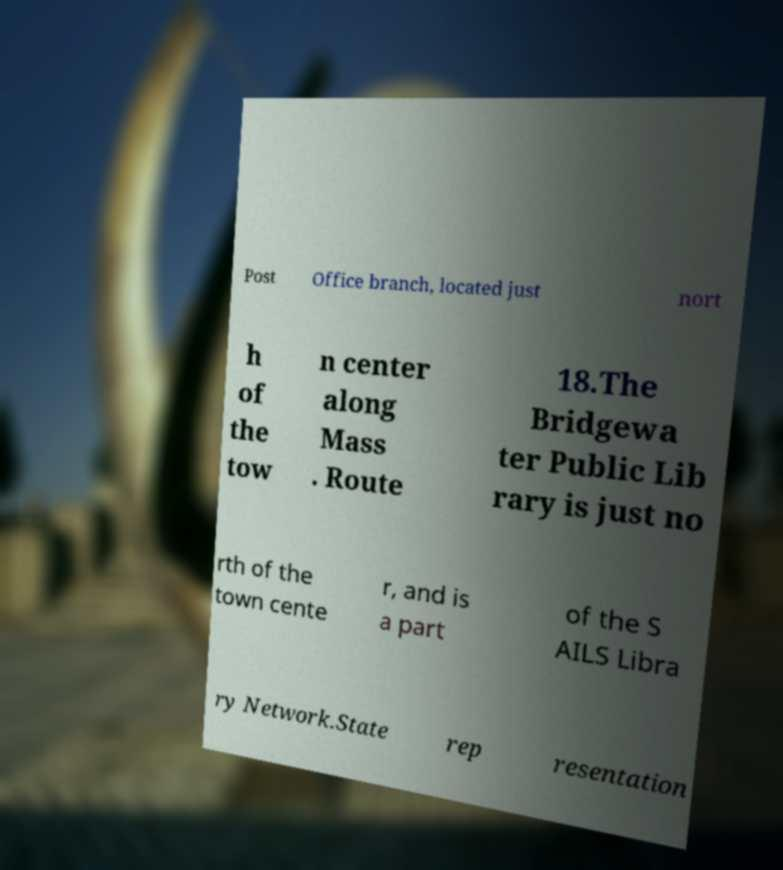Can you accurately transcribe the text from the provided image for me? Post Office branch, located just nort h of the tow n center along Mass . Route 18.The Bridgewa ter Public Lib rary is just no rth of the town cente r, and is a part of the S AILS Libra ry Network.State rep resentation 